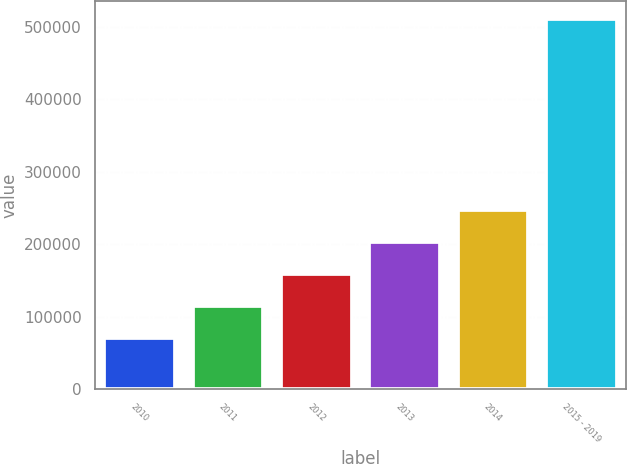Convert chart. <chart><loc_0><loc_0><loc_500><loc_500><bar_chart><fcel>2010<fcel>2011<fcel>2012<fcel>2013<fcel>2014<fcel>2015 - 2019<nl><fcel>71439<fcel>115386<fcel>159334<fcel>203281<fcel>247229<fcel>510913<nl></chart> 